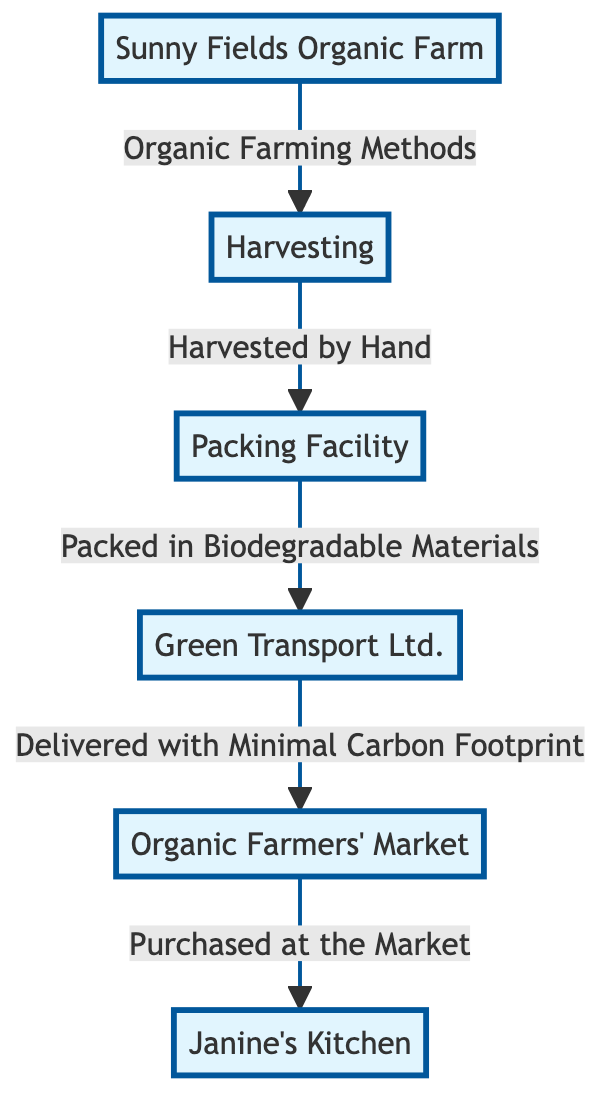What is the first step in Janine’s food chain? The diagram starts with "Sunny Fields Organic Farm," indicating that it is the initial point where the food chain begins.
Answer: Sunny Fields Organic Farm How are the organic produce harvested? The flow from the "Harvesting" node indicates that the produce is "Harvested by Hand," describing the method of harvesting.
Answer: Harvested by Hand What material is used for packing the harvested produce? The arrow from "Packing Facility" specifies that the produce is "Packed in Biodegradable Materials," illustrating the type of packing used.
Answer: Biodegradable Materials What type of transport is used for delivery? According to the flow from "Packing Facility" to "Green Transport Ltd.," the produce is delivered via "Green Transport Ltd.," emphasizing environmentally friendly transport.
Answer: Green Transport Ltd How does the produce reach Janine's kitchen? The flow from "Organic Farmers' Market" indicates that the produce is "Purchased at the Market," which means it's acquired by Janine from there.
Answer: Purchased at the Market What is a characteristic feature of the transport process? The connection from "Transport" to "Market" highlights that the delivery is done with "Minimal Carbon Footprint," indicating an eco-friendly transport method.
Answer: Minimal Carbon Footprint How many nodes are there in the food chain? The diagram includes six distinct nodes: "Sunny Fields Organic Farm," "Harvesting," "Packing Facility," "Green Transport Ltd.," "Organic Farmers' Market," and "Janine's Kitchen." By counting these, we find there are six nodes in total.
Answer: 6 What is the connection between the packing and transport stages? The direct connection from "Packing Facility" to "Green Transport Ltd." shows that after packing, the next step is to transport the produce, indicating a sequential relationship between these two processes.
Answer: Sequential Relationship What farm method is employed to grow the produce? The flow from "Sunny Fields Organic Farm" states that the produce is cultivated using "Organic Farming Methods," defining the agricultural practice used.
Answer: Organic Farming Methods 